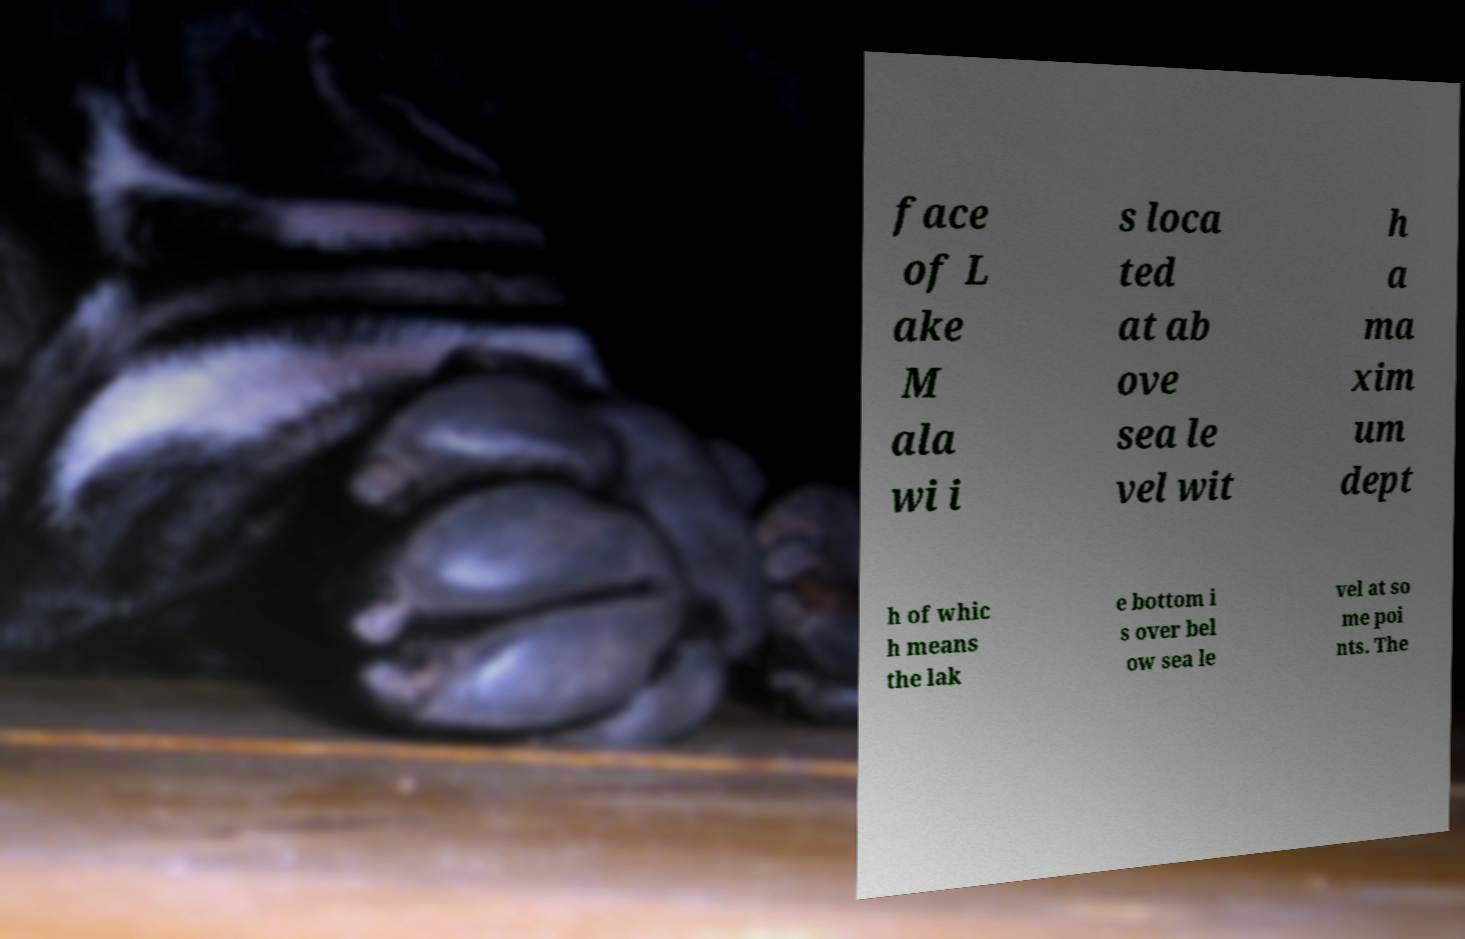For documentation purposes, I need the text within this image transcribed. Could you provide that? face of L ake M ala wi i s loca ted at ab ove sea le vel wit h a ma xim um dept h of whic h means the lak e bottom i s over bel ow sea le vel at so me poi nts. The 